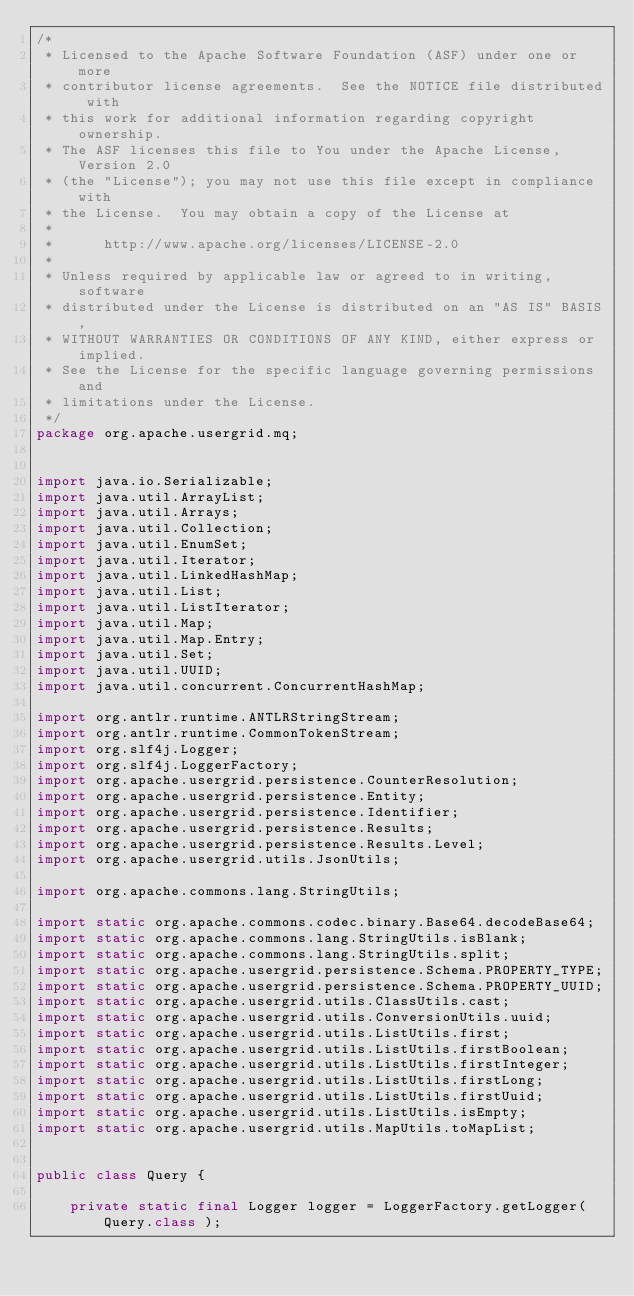Convert code to text. <code><loc_0><loc_0><loc_500><loc_500><_Java_>/*
 * Licensed to the Apache Software Foundation (ASF) under one or more
 * contributor license agreements.  See the NOTICE file distributed with
 * this work for additional information regarding copyright ownership.
 * The ASF licenses this file to You under the Apache License, Version 2.0
 * (the "License"); you may not use this file except in compliance with
 * the License.  You may obtain a copy of the License at
 *
 *      http://www.apache.org/licenses/LICENSE-2.0
 *
 * Unless required by applicable law or agreed to in writing, software
 * distributed under the License is distributed on an "AS IS" BASIS,
 * WITHOUT WARRANTIES OR CONDITIONS OF ANY KIND, either express or implied.
 * See the License for the specific language governing permissions and
 * limitations under the License.
 */
package org.apache.usergrid.mq;


import java.io.Serializable;
import java.util.ArrayList;
import java.util.Arrays;
import java.util.Collection;
import java.util.EnumSet;
import java.util.Iterator;
import java.util.LinkedHashMap;
import java.util.List;
import java.util.ListIterator;
import java.util.Map;
import java.util.Map.Entry;
import java.util.Set;
import java.util.UUID;
import java.util.concurrent.ConcurrentHashMap;

import org.antlr.runtime.ANTLRStringStream;
import org.antlr.runtime.CommonTokenStream;
import org.slf4j.Logger;
import org.slf4j.LoggerFactory;
import org.apache.usergrid.persistence.CounterResolution;
import org.apache.usergrid.persistence.Entity;
import org.apache.usergrid.persistence.Identifier;
import org.apache.usergrid.persistence.Results;
import org.apache.usergrid.persistence.Results.Level;
import org.apache.usergrid.utils.JsonUtils;

import org.apache.commons.lang.StringUtils;

import static org.apache.commons.codec.binary.Base64.decodeBase64;
import static org.apache.commons.lang.StringUtils.isBlank;
import static org.apache.commons.lang.StringUtils.split;
import static org.apache.usergrid.persistence.Schema.PROPERTY_TYPE;
import static org.apache.usergrid.persistence.Schema.PROPERTY_UUID;
import static org.apache.usergrid.utils.ClassUtils.cast;
import static org.apache.usergrid.utils.ConversionUtils.uuid;
import static org.apache.usergrid.utils.ListUtils.first;
import static org.apache.usergrid.utils.ListUtils.firstBoolean;
import static org.apache.usergrid.utils.ListUtils.firstInteger;
import static org.apache.usergrid.utils.ListUtils.firstLong;
import static org.apache.usergrid.utils.ListUtils.firstUuid;
import static org.apache.usergrid.utils.ListUtils.isEmpty;
import static org.apache.usergrid.utils.MapUtils.toMapList;


public class Query {

    private static final Logger logger = LoggerFactory.getLogger( Query.class );
</code> 